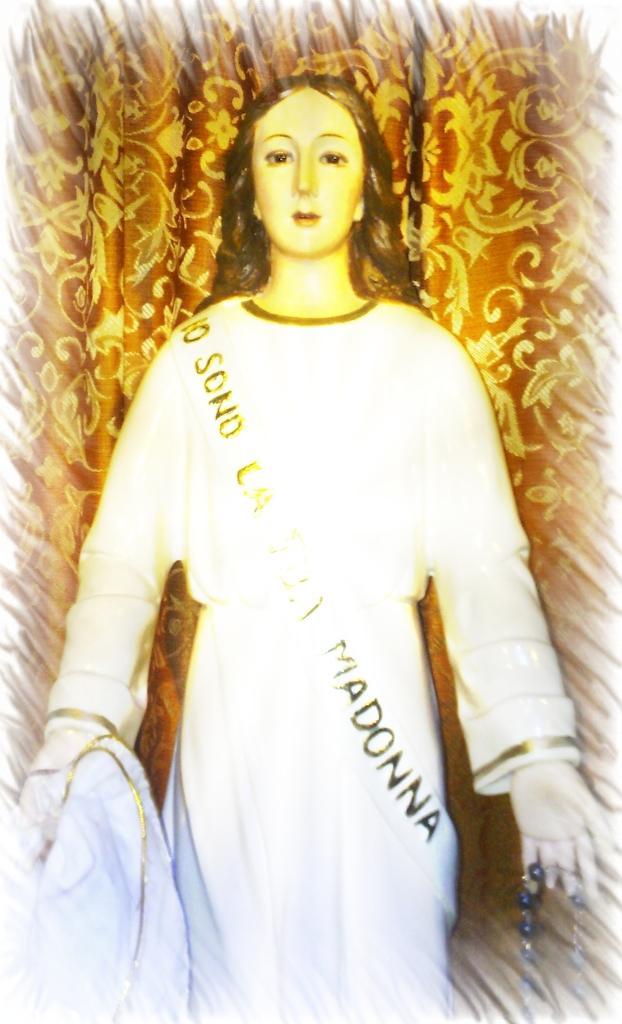Describe this image in one or two sentences. In this image I can see the statue of the person and I can see the brown color background. 